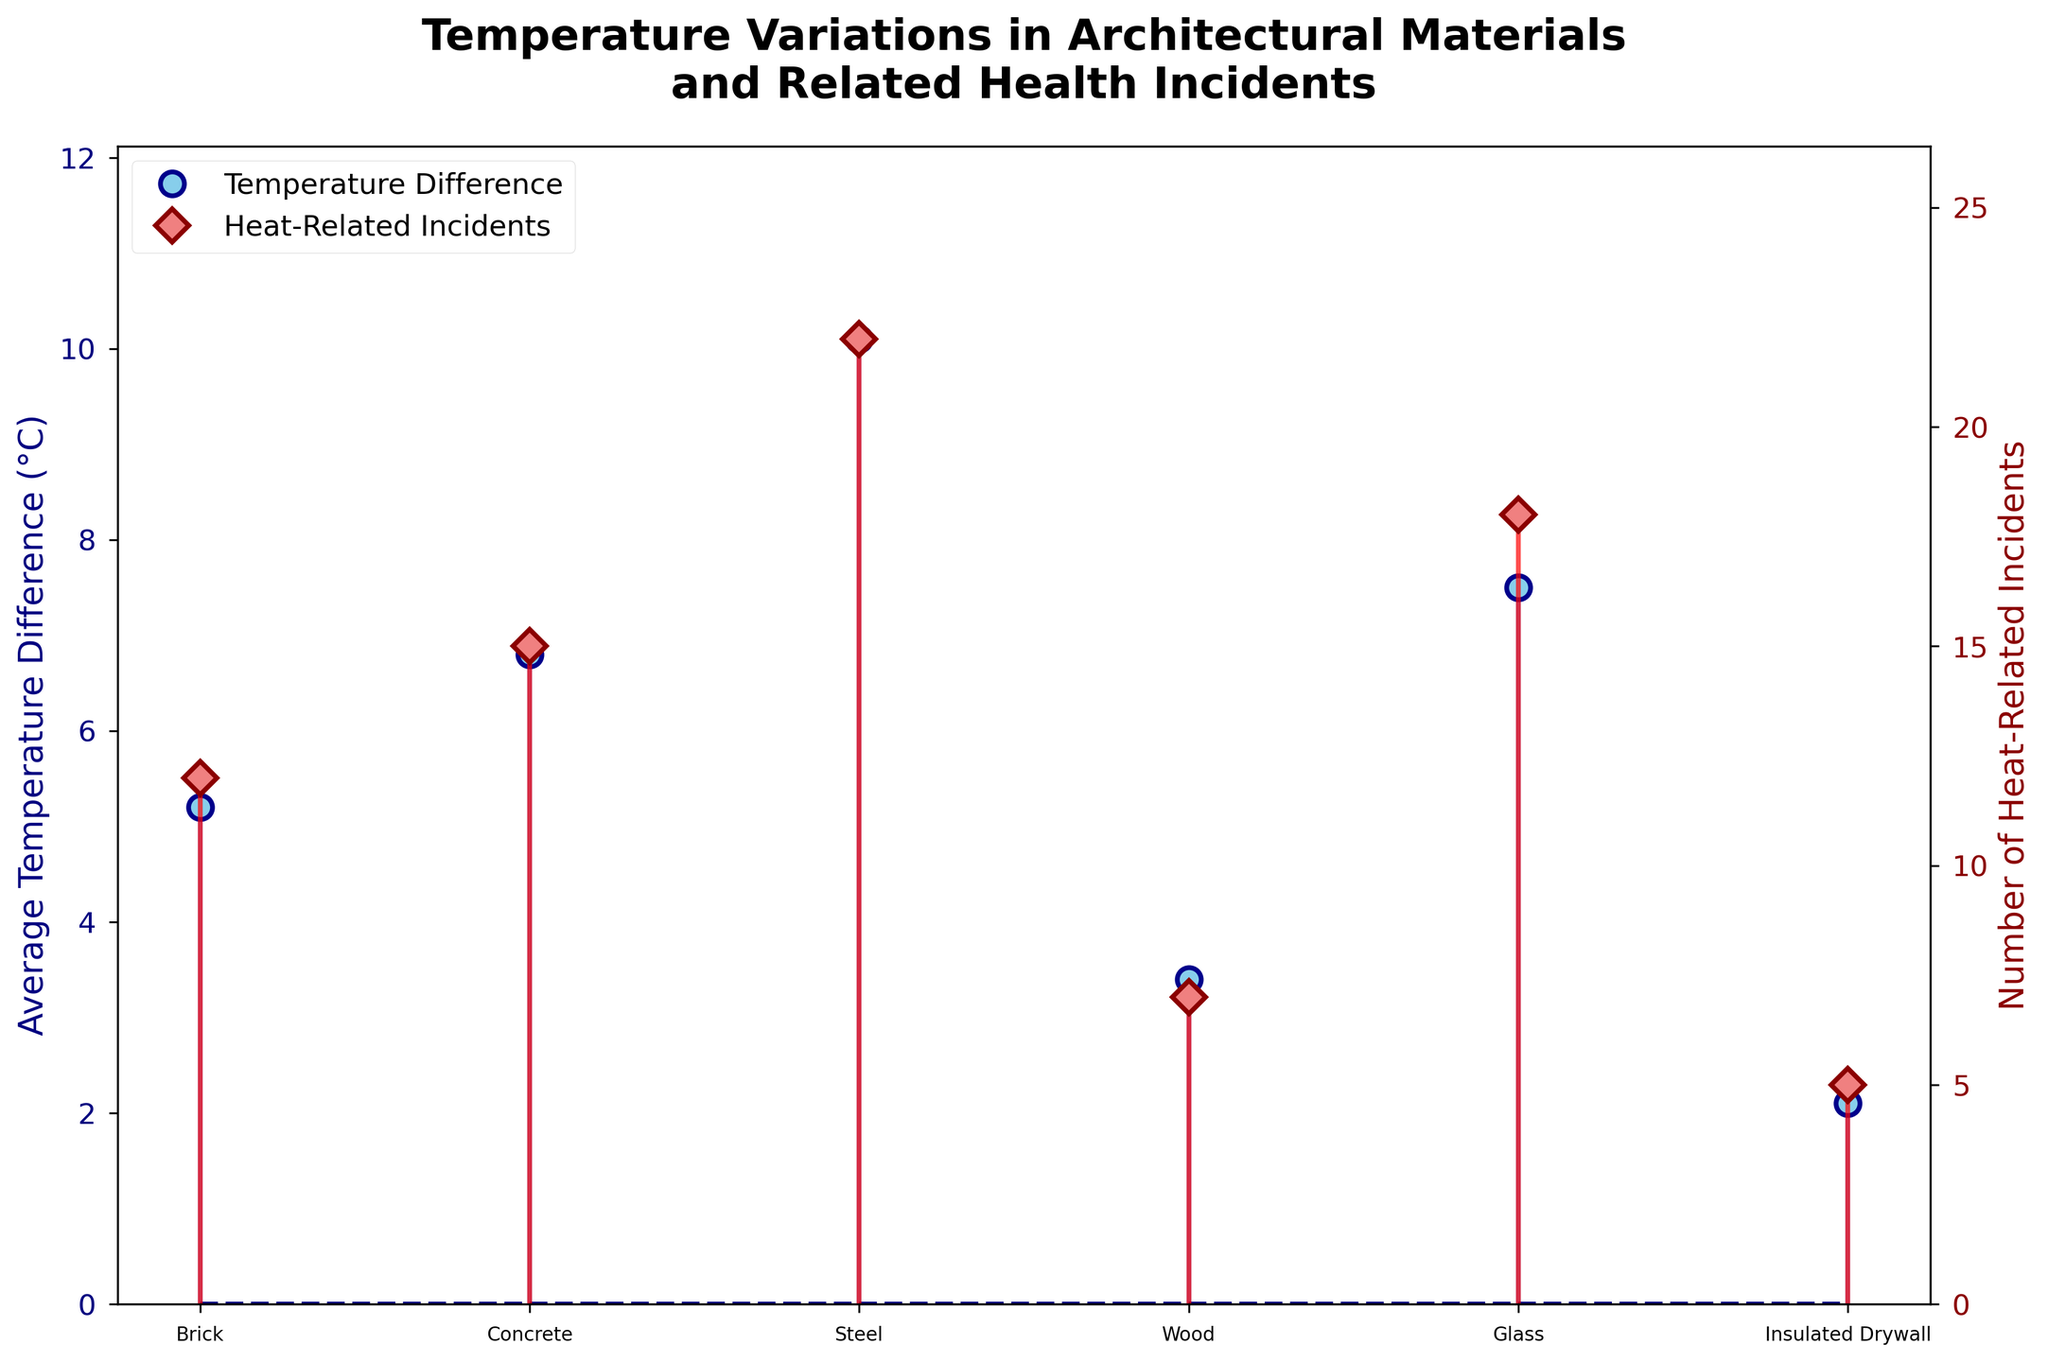What's the title of the figure? The title of the figure can be found at the top in bold.
Answer: Temperature Variations in Architectural Materials and Related Health Incidents What materials have the lowest average temperature difference? By looking at the stem plot for the temperature difference, the lowest point is for Insulated Drywall.
Answer: Insulated Drywall Which material has the highest number of heat-related incidents? By observing the stem lines for the heat-related incidents, the highest point is for Steel.
Answer: Steel What's the difference in heat-related incidents between the material with the highest and the lowest incidents? Steel has the highest number of incidents (22) and Insulated Drywall has the lowest (5). Calculating the difference: 22 - 5.
Answer: 17 Compare the average temperature difference between Brick and Steel. Which one is higher and by how much? The stem plot shows Brick has a temperature difference of 5.2°C and Steel has 10.1°C. To find the difference: 10.1 - 5.2.
Answer: Steel by 4.9°C What's the total number of heat-related incidents across all materials? Summing the number of heat-related incidents for all materials: 12 (Brick) + 15 (Concrete) + 22 (Steel) + 7 (Wood) + 18 (Glass) + 5 (Insulated Drywall).
Answer: 79 Which materials have an average temperature difference greater than 6°C? By observing the temperature stems, the materials are Concrete, Steel, and Glass.
Answer: Concrete, Steel, Glass What is the range of average temperature differences among the materials? The range is found by subtracting the smallest average temperature difference (Insulated Drywall - 2.1°C) from the largest (Steel - 10.1°C): 10.1 - 2.1.
Answer: 8°C Is there a material where the number of heat-related incidents is less than 10? If yes, name them. By looking at the stem plot for heat-related incidents, Wood (7) and Insulated Drywall (5) have incidents less than 10.
Answer: Wood, Insulated Drywall How does the number of heat-related incidents for Glass compare to that for Concrete? The stem plot shows Glass has 18 incidents and Concrete has 15. Comparing them: 18 - 15.
Answer: Glass has 3 more incidents than Concrete 